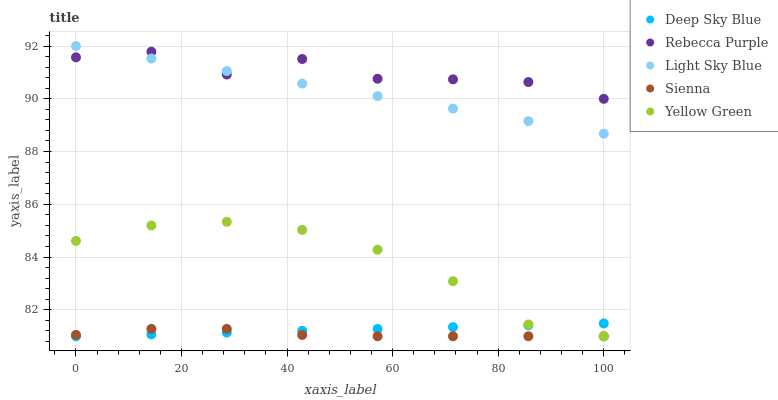Does Sienna have the minimum area under the curve?
Answer yes or no. Yes. Does Rebecca Purple have the maximum area under the curve?
Answer yes or no. Yes. Does Light Sky Blue have the minimum area under the curve?
Answer yes or no. No. Does Light Sky Blue have the maximum area under the curve?
Answer yes or no. No. Is Light Sky Blue the smoothest?
Answer yes or no. Yes. Is Rebecca Purple the roughest?
Answer yes or no. Yes. Is Rebecca Purple the smoothest?
Answer yes or no. No. Is Light Sky Blue the roughest?
Answer yes or no. No. Does Sienna have the lowest value?
Answer yes or no. Yes. Does Light Sky Blue have the lowest value?
Answer yes or no. No. Does Light Sky Blue have the highest value?
Answer yes or no. Yes. Does Rebecca Purple have the highest value?
Answer yes or no. No. Is Yellow Green less than Light Sky Blue?
Answer yes or no. Yes. Is Light Sky Blue greater than Deep Sky Blue?
Answer yes or no. Yes. Does Yellow Green intersect Deep Sky Blue?
Answer yes or no. Yes. Is Yellow Green less than Deep Sky Blue?
Answer yes or no. No. Is Yellow Green greater than Deep Sky Blue?
Answer yes or no. No. Does Yellow Green intersect Light Sky Blue?
Answer yes or no. No. 